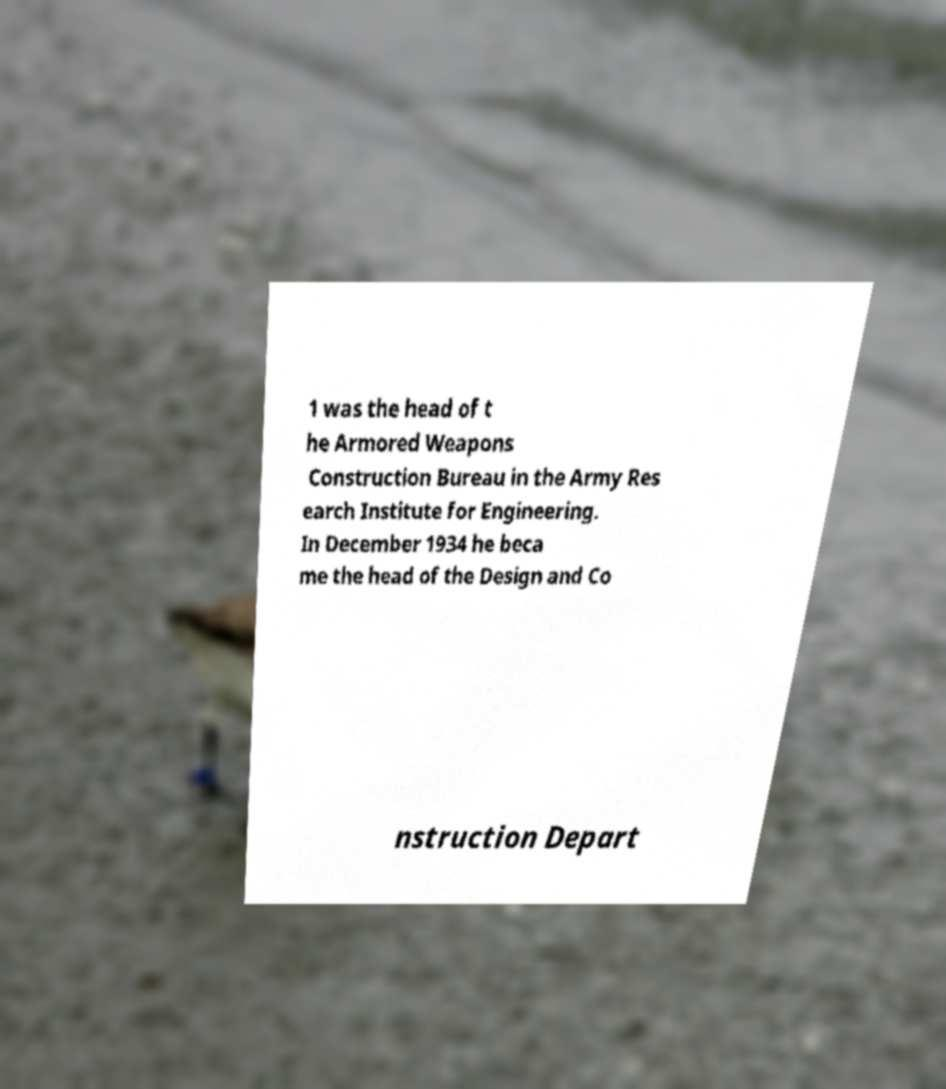Can you accurately transcribe the text from the provided image for me? 1 was the head of t he Armored Weapons Construction Bureau in the Army Res earch Institute for Engineering. In December 1934 he beca me the head of the Design and Co nstruction Depart 